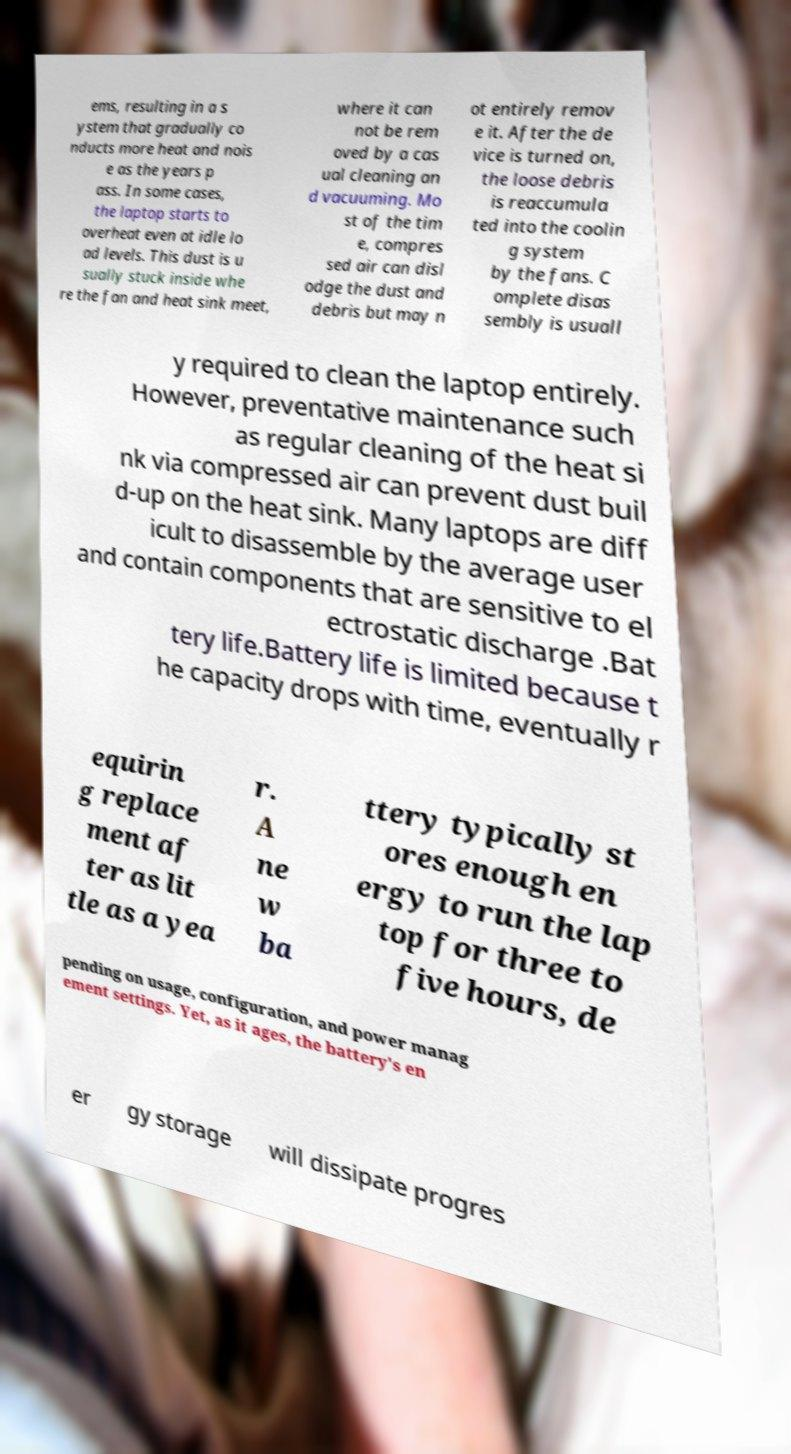What messages or text are displayed in this image? I need them in a readable, typed format. ems, resulting in a s ystem that gradually co nducts more heat and nois e as the years p ass. In some cases, the laptop starts to overheat even at idle lo ad levels. This dust is u sually stuck inside whe re the fan and heat sink meet, where it can not be rem oved by a cas ual cleaning an d vacuuming. Mo st of the tim e, compres sed air can disl odge the dust and debris but may n ot entirely remov e it. After the de vice is turned on, the loose debris is reaccumula ted into the coolin g system by the fans. C omplete disas sembly is usuall y required to clean the laptop entirely. However, preventative maintenance such as regular cleaning of the heat si nk via compressed air can prevent dust buil d-up on the heat sink. Many laptops are diff icult to disassemble by the average user and contain components that are sensitive to el ectrostatic discharge .Bat tery life.Battery life is limited because t he capacity drops with time, eventually r equirin g replace ment af ter as lit tle as a yea r. A ne w ba ttery typically st ores enough en ergy to run the lap top for three to five hours, de pending on usage, configuration, and power manag ement settings. Yet, as it ages, the battery's en er gy storage will dissipate progres 